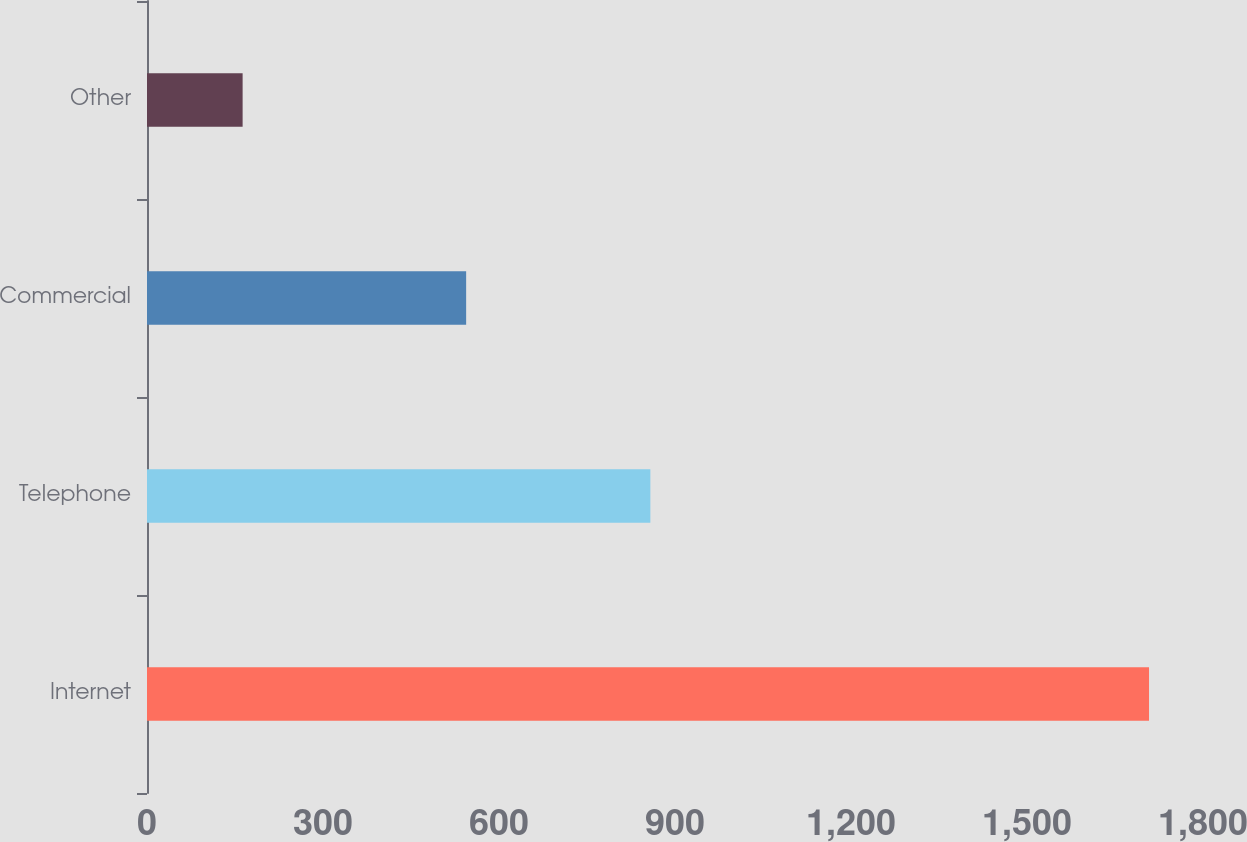<chart> <loc_0><loc_0><loc_500><loc_500><bar_chart><fcel>Internet<fcel>Telephone<fcel>Commercial<fcel>Other<nl><fcel>1708<fcel>858<fcel>544<fcel>163<nl></chart> 